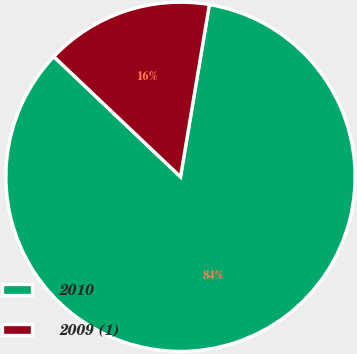Convert chart to OTSL. <chart><loc_0><loc_0><loc_500><loc_500><pie_chart><fcel>2010<fcel>2009 (1)<nl><fcel>84.44%<fcel>15.56%<nl></chart> 